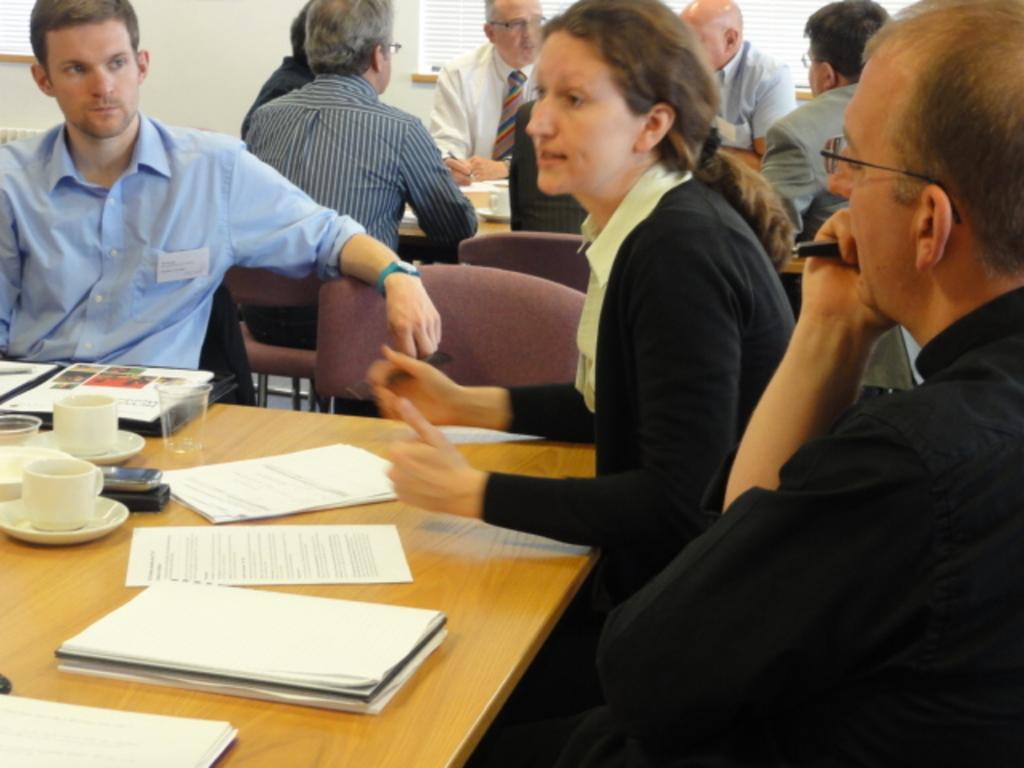Can you describe this image briefly? on the right a man is sitting in the middle a woman is sitting and talking. There are papers books on the table and tea cups, glasses. 